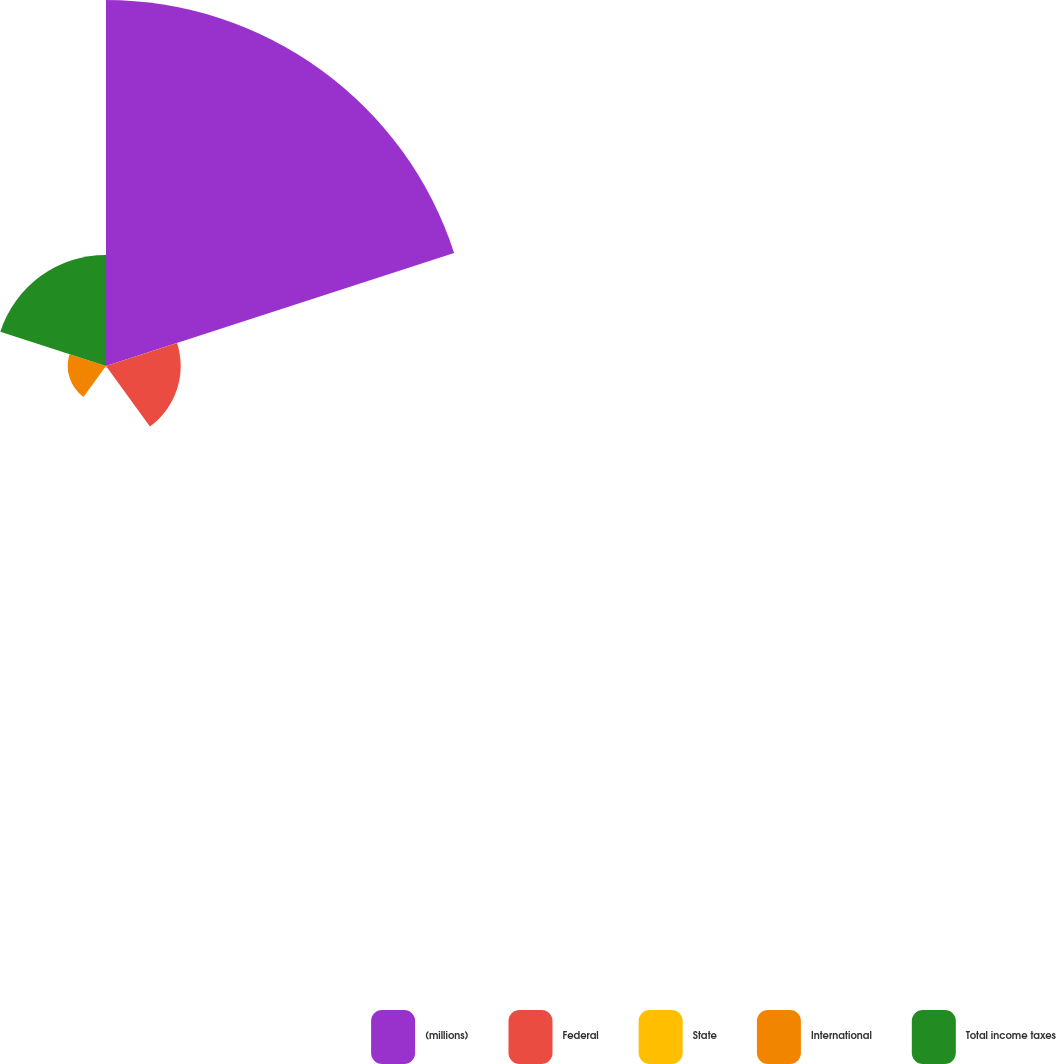Convert chart to OTSL. <chart><loc_0><loc_0><loc_500><loc_500><pie_chart><fcel>(millions)<fcel>Federal<fcel>State<fcel>International<fcel>Total income taxes<nl><fcel>61.83%<fcel>12.62%<fcel>0.32%<fcel>6.47%<fcel>18.77%<nl></chart> 